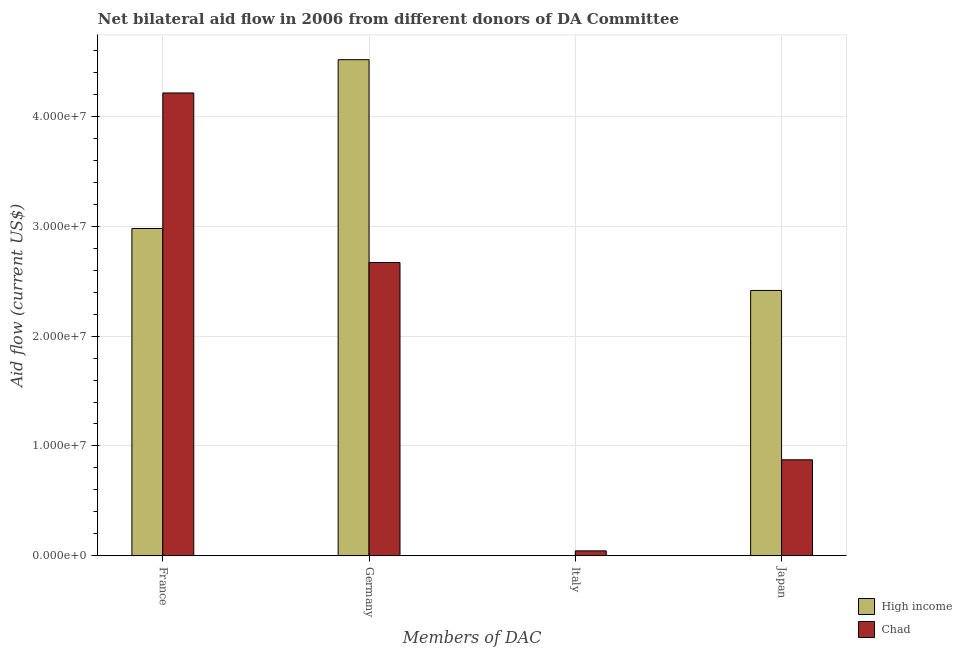How many bars are there on the 1st tick from the left?
Your answer should be compact. 2. How many bars are there on the 2nd tick from the right?
Keep it short and to the point. 1. What is the label of the 3rd group of bars from the left?
Offer a very short reply. Italy. Across all countries, what is the maximum amount of aid given by france?
Make the answer very short. 4.21e+07. Across all countries, what is the minimum amount of aid given by japan?
Keep it short and to the point. 8.74e+06. What is the total amount of aid given by japan in the graph?
Make the answer very short. 3.29e+07. What is the difference between the amount of aid given by germany in High income and that in Chad?
Offer a terse response. 1.85e+07. What is the difference between the amount of aid given by germany in High income and the amount of aid given by italy in Chad?
Keep it short and to the point. 4.47e+07. What is the average amount of aid given by germany per country?
Your response must be concise. 3.59e+07. What is the difference between the amount of aid given by japan and amount of aid given by germany in Chad?
Offer a terse response. -1.80e+07. What is the ratio of the amount of aid given by japan in High income to that in Chad?
Provide a short and direct response. 2.76. What is the difference between the highest and the second highest amount of aid given by germany?
Provide a short and direct response. 1.85e+07. What is the difference between the highest and the lowest amount of aid given by germany?
Make the answer very short. 1.85e+07. What is the difference between two consecutive major ticks on the Y-axis?
Provide a short and direct response. 1.00e+07. Where does the legend appear in the graph?
Provide a short and direct response. Bottom right. How are the legend labels stacked?
Your response must be concise. Vertical. What is the title of the graph?
Ensure brevity in your answer.  Net bilateral aid flow in 2006 from different donors of DA Committee. What is the label or title of the X-axis?
Your answer should be very brief. Members of DAC. What is the Aid flow (current US$) of High income in France?
Provide a succinct answer. 2.98e+07. What is the Aid flow (current US$) of Chad in France?
Your response must be concise. 4.21e+07. What is the Aid flow (current US$) in High income in Germany?
Make the answer very short. 4.52e+07. What is the Aid flow (current US$) in Chad in Germany?
Your response must be concise. 2.67e+07. What is the Aid flow (current US$) in High income in Italy?
Provide a short and direct response. 0. What is the Aid flow (current US$) of High income in Japan?
Ensure brevity in your answer.  2.42e+07. What is the Aid flow (current US$) of Chad in Japan?
Offer a very short reply. 8.74e+06. Across all Members of DAC, what is the maximum Aid flow (current US$) in High income?
Make the answer very short. 4.52e+07. Across all Members of DAC, what is the maximum Aid flow (current US$) in Chad?
Offer a very short reply. 4.21e+07. What is the total Aid flow (current US$) of High income in the graph?
Keep it short and to the point. 9.91e+07. What is the total Aid flow (current US$) of Chad in the graph?
Your answer should be very brief. 7.80e+07. What is the difference between the Aid flow (current US$) in High income in France and that in Germany?
Give a very brief answer. -1.54e+07. What is the difference between the Aid flow (current US$) in Chad in France and that in Germany?
Keep it short and to the point. 1.54e+07. What is the difference between the Aid flow (current US$) of Chad in France and that in Italy?
Give a very brief answer. 4.17e+07. What is the difference between the Aid flow (current US$) in High income in France and that in Japan?
Offer a terse response. 5.64e+06. What is the difference between the Aid flow (current US$) of Chad in France and that in Japan?
Your answer should be very brief. 3.34e+07. What is the difference between the Aid flow (current US$) of Chad in Germany and that in Italy?
Provide a short and direct response. 2.62e+07. What is the difference between the Aid flow (current US$) of High income in Germany and that in Japan?
Your response must be concise. 2.10e+07. What is the difference between the Aid flow (current US$) in Chad in Germany and that in Japan?
Provide a short and direct response. 1.80e+07. What is the difference between the Aid flow (current US$) in Chad in Italy and that in Japan?
Your response must be concise. -8.29e+06. What is the difference between the Aid flow (current US$) in High income in France and the Aid flow (current US$) in Chad in Germany?
Ensure brevity in your answer.  3.10e+06. What is the difference between the Aid flow (current US$) of High income in France and the Aid flow (current US$) of Chad in Italy?
Make the answer very short. 2.94e+07. What is the difference between the Aid flow (current US$) of High income in France and the Aid flow (current US$) of Chad in Japan?
Give a very brief answer. 2.11e+07. What is the difference between the Aid flow (current US$) of High income in Germany and the Aid flow (current US$) of Chad in Italy?
Your answer should be compact. 4.47e+07. What is the difference between the Aid flow (current US$) of High income in Germany and the Aid flow (current US$) of Chad in Japan?
Provide a short and direct response. 3.64e+07. What is the average Aid flow (current US$) of High income per Members of DAC?
Offer a very short reply. 2.48e+07. What is the average Aid flow (current US$) of Chad per Members of DAC?
Keep it short and to the point. 1.95e+07. What is the difference between the Aid flow (current US$) of High income and Aid flow (current US$) of Chad in France?
Your response must be concise. -1.23e+07. What is the difference between the Aid flow (current US$) of High income and Aid flow (current US$) of Chad in Germany?
Keep it short and to the point. 1.85e+07. What is the difference between the Aid flow (current US$) in High income and Aid flow (current US$) in Chad in Japan?
Your response must be concise. 1.54e+07. What is the ratio of the Aid flow (current US$) of High income in France to that in Germany?
Make the answer very short. 0.66. What is the ratio of the Aid flow (current US$) of Chad in France to that in Germany?
Offer a very short reply. 1.58. What is the ratio of the Aid flow (current US$) in Chad in France to that in Italy?
Provide a short and direct response. 93.64. What is the ratio of the Aid flow (current US$) of High income in France to that in Japan?
Offer a very short reply. 1.23. What is the ratio of the Aid flow (current US$) of Chad in France to that in Japan?
Make the answer very short. 4.82. What is the ratio of the Aid flow (current US$) in Chad in Germany to that in Italy?
Offer a very short reply. 59.33. What is the ratio of the Aid flow (current US$) of High income in Germany to that in Japan?
Give a very brief answer. 1.87. What is the ratio of the Aid flow (current US$) of Chad in Germany to that in Japan?
Offer a very short reply. 3.05. What is the ratio of the Aid flow (current US$) in Chad in Italy to that in Japan?
Your answer should be compact. 0.05. What is the difference between the highest and the second highest Aid flow (current US$) in High income?
Make the answer very short. 1.54e+07. What is the difference between the highest and the second highest Aid flow (current US$) in Chad?
Provide a short and direct response. 1.54e+07. What is the difference between the highest and the lowest Aid flow (current US$) in High income?
Your response must be concise. 4.52e+07. What is the difference between the highest and the lowest Aid flow (current US$) of Chad?
Give a very brief answer. 4.17e+07. 